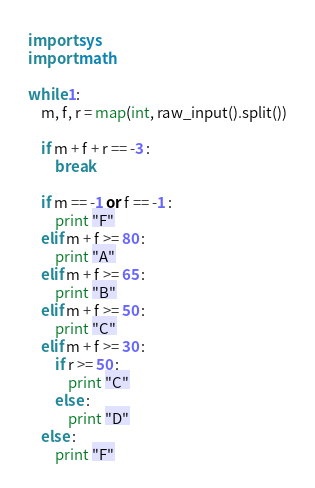Convert code to text. <code><loc_0><loc_0><loc_500><loc_500><_Python_>import sys
import math

while 1:
    m, f, r = map(int, raw_input().split())

    if m + f + r == -3 :
        break

    if m == -1 or f == -1 :
        print "F"
    elif m + f >= 80 :
        print "A"
    elif m + f >= 65 :
        print "B"
    elif m + f >= 50 :
        print "C"
    elif m + f >= 30 :
        if r >= 50 :
            print "C"
        else :
            print "D"
    else :
        print "F"</code> 